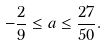<formula> <loc_0><loc_0><loc_500><loc_500>- \frac { 2 } { 9 } \leq a \leq \frac { 2 7 } { 5 0 } .</formula> 